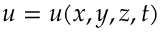<formula> <loc_0><loc_0><loc_500><loc_500>u = u ( x , y , z , t )</formula> 